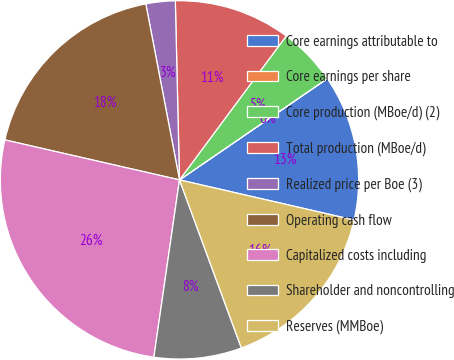Convert chart to OTSL. <chart><loc_0><loc_0><loc_500><loc_500><pie_chart><fcel>Core earnings attributable to<fcel>Core earnings per share<fcel>Core production (MBoe/d) (2)<fcel>Total production (MBoe/d)<fcel>Realized price per Boe (3)<fcel>Operating cash flow<fcel>Capitalized costs including<fcel>Shareholder and noncontrolling<fcel>Reserves (MMBoe)<nl><fcel>13.16%<fcel>0.01%<fcel>5.27%<fcel>10.53%<fcel>2.64%<fcel>18.41%<fcel>26.3%<fcel>7.9%<fcel>15.79%<nl></chart> 